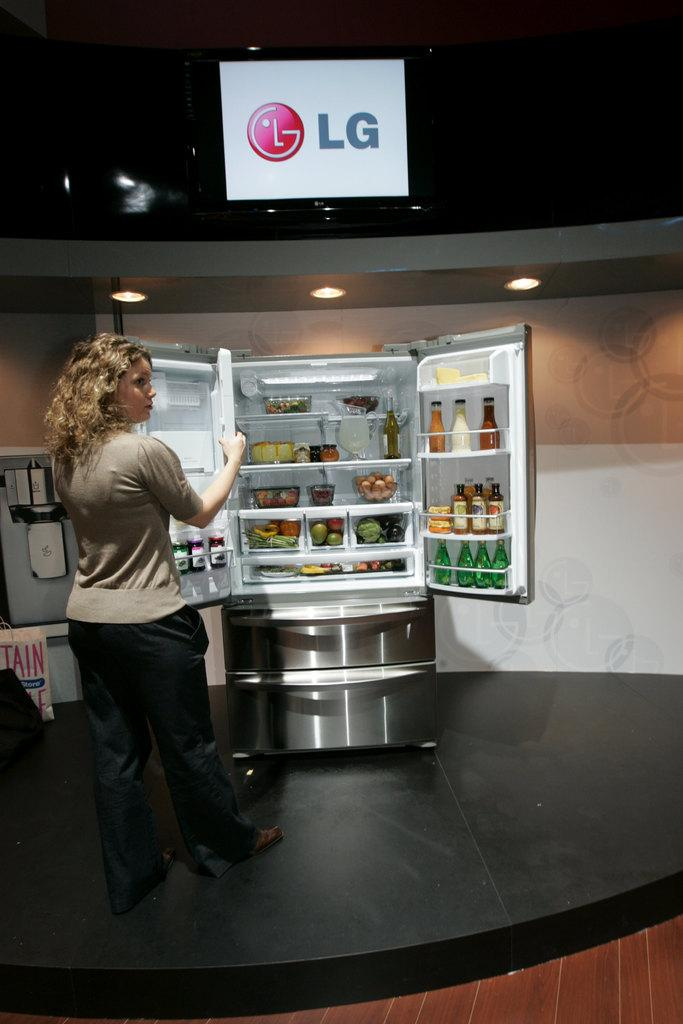<image>
Give a short and clear explanation of the subsequent image. A woman opening a LG refrigerator that contains food and drinks. 